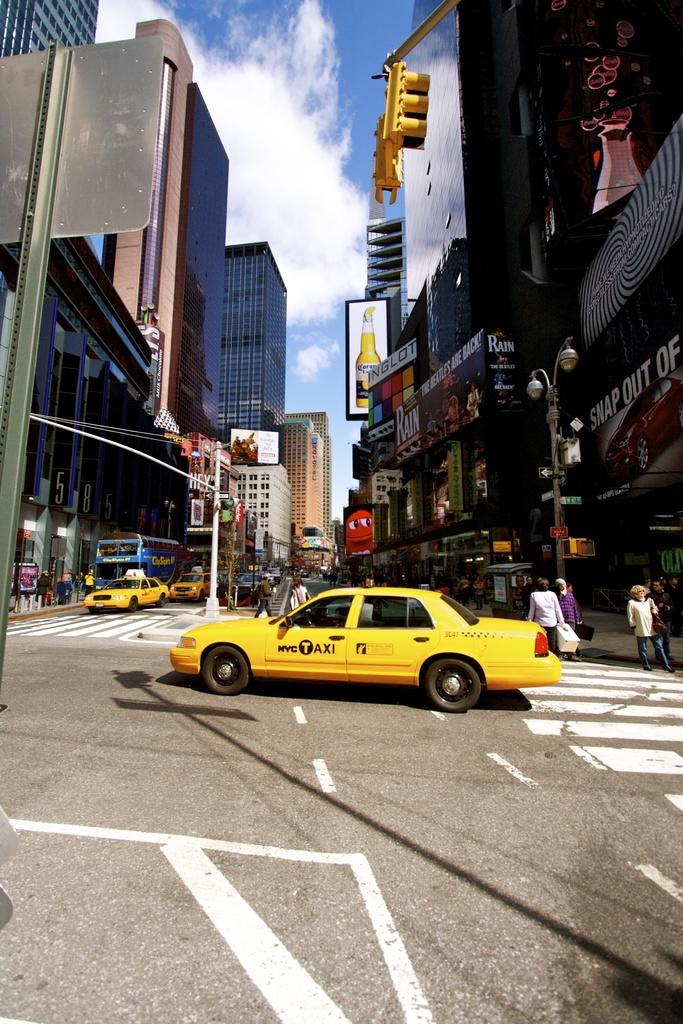<image>
Provide a brief description of the given image. the word taxi that is on the side of a car 